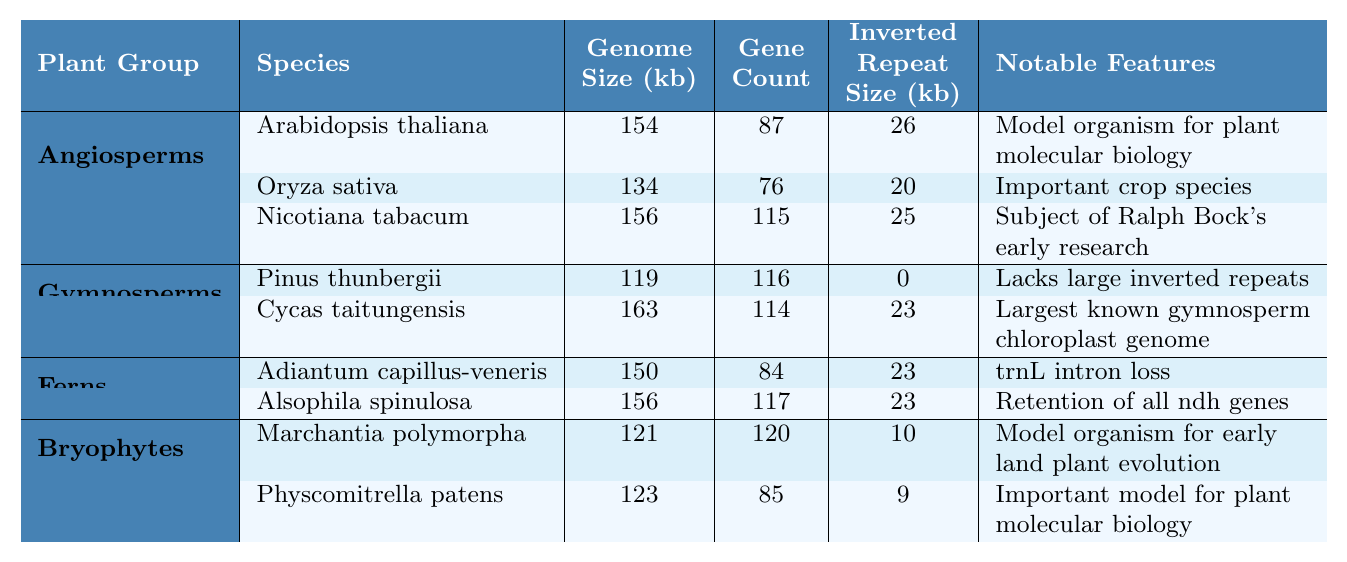What is the genome size of Nicotiana tabacum? The table shows that the genome size of Nicotiana tabacum in kilobases (kb) is listed directly under the "Genome Size (kb)" column for that species. The entry shows a genome size of 156 kb.
Answer: 156 kb Which plant group has the largest average genome size? To find the average genome size for each plant group, we add the genome sizes of each species in the group and divide by the number of species in that group. For Angiosperms: (154 + 134 + 156) / 3 = 148 kb. For Gymnosperms: (119 + 163) / 2 = 141 kb. For Ferns: (150 + 156) / 2 = 153 kb. For Bryophytes: (121 + 123) / 2 = 122 kb. The largest average is from Ferns, at 153 kb.
Answer: Ferns Does any species in the Gymnosperms group lack inverted repeats? The table indicates whether species have an inverted repeat size by showing a "0" for Pinus thunbergii. This indicates that it lacks large inverted repeats.
Answer: Yes What is the total gene count for all species in the Bryophytes group? We add the gene counts of the two species in the Bryophytes group as indicated in the "Gene Count" column: Marchantia polymorpha has 120 and Physcomitrella patens has 85. Therefore, 120 + 85 = 205.
Answer: 205 Which species has the highest gene count among all listed? We will look at the "Gene Count" column for all species. Comparing the values: Arabidopsis thaliana (87), Oryza sativa (76), Nicotiana tabacum (115), Pinus thunbergii (116), Cycas taitungensis (114), Adiantum capillus-veneris (84), Alsophila spinulosa (117), Marchantia polymorpha (120), and Physcomitrella patens (85), we determine that Nicotiana tabacum has the highest gene count at 115.
Answer: Nicotiana tabacum Is the inverted repeat size of Arabidopsis thaliana greater than that of Oryza sativa? We will refer to the "Inverted Repeat Size (kb)" column. Arabidopsis thaliana has an inverted repeat size of 26 kb, while Oryza sativa has 20 kb. Since 26 kb is greater than 20 kb, the statement is true.
Answer: Yes What notable feature is shared between all species in the Angiosperms group? Looking at the "Notable Features" column for each species in the Angiosperms group, we see that each feature is unique to the species. Therefore, there is no shared notable feature among them.
Answer: None 